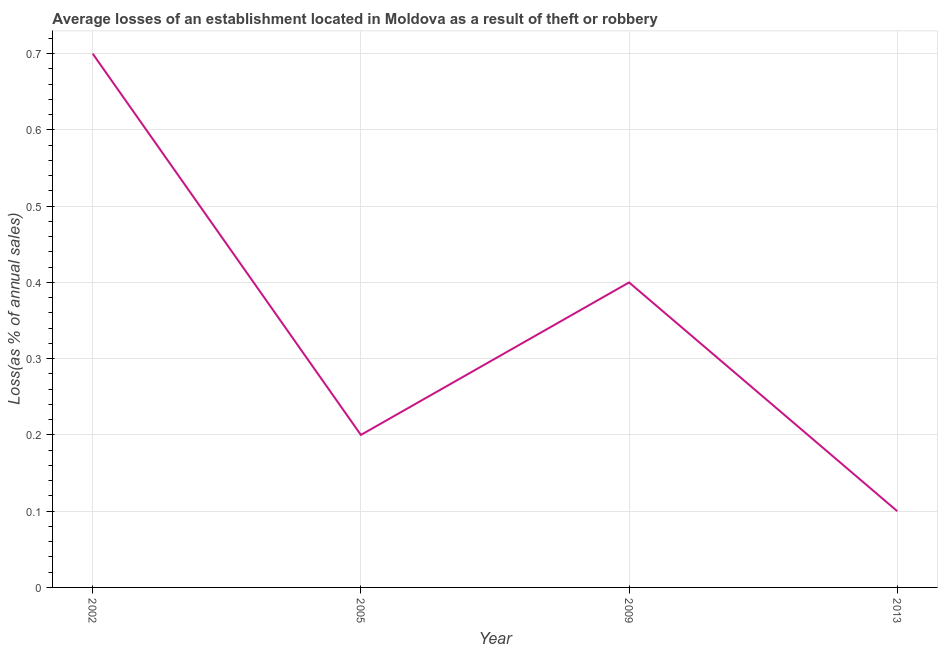What is the losses due to theft in 2013?
Ensure brevity in your answer.  0.1. Across all years, what is the minimum losses due to theft?
Keep it short and to the point. 0.1. In which year was the losses due to theft minimum?
Make the answer very short. 2013. What is the difference between the losses due to theft in 2002 and 2009?
Provide a succinct answer. 0.3. What is the median losses due to theft?
Provide a succinct answer. 0.3. In how many years, is the losses due to theft greater than 0.06 %?
Make the answer very short. 4. What is the ratio of the losses due to theft in 2002 to that in 2013?
Your response must be concise. 7. Is the losses due to theft in 2002 less than that in 2005?
Your answer should be very brief. No. What is the difference between the highest and the second highest losses due to theft?
Give a very brief answer. 0.3. What is the difference between the highest and the lowest losses due to theft?
Offer a terse response. 0.6. Are the values on the major ticks of Y-axis written in scientific E-notation?
Ensure brevity in your answer.  No. What is the title of the graph?
Give a very brief answer. Average losses of an establishment located in Moldova as a result of theft or robbery. What is the label or title of the X-axis?
Your response must be concise. Year. What is the label or title of the Y-axis?
Provide a succinct answer. Loss(as % of annual sales). What is the Loss(as % of annual sales) of 2009?
Ensure brevity in your answer.  0.4. What is the difference between the Loss(as % of annual sales) in 2005 and 2009?
Your answer should be compact. -0.2. What is the difference between the Loss(as % of annual sales) in 2005 and 2013?
Your answer should be compact. 0.1. What is the ratio of the Loss(as % of annual sales) in 2002 to that in 2005?
Offer a terse response. 3.5. What is the ratio of the Loss(as % of annual sales) in 2002 to that in 2009?
Make the answer very short. 1.75. What is the ratio of the Loss(as % of annual sales) in 2005 to that in 2013?
Your answer should be compact. 2. 